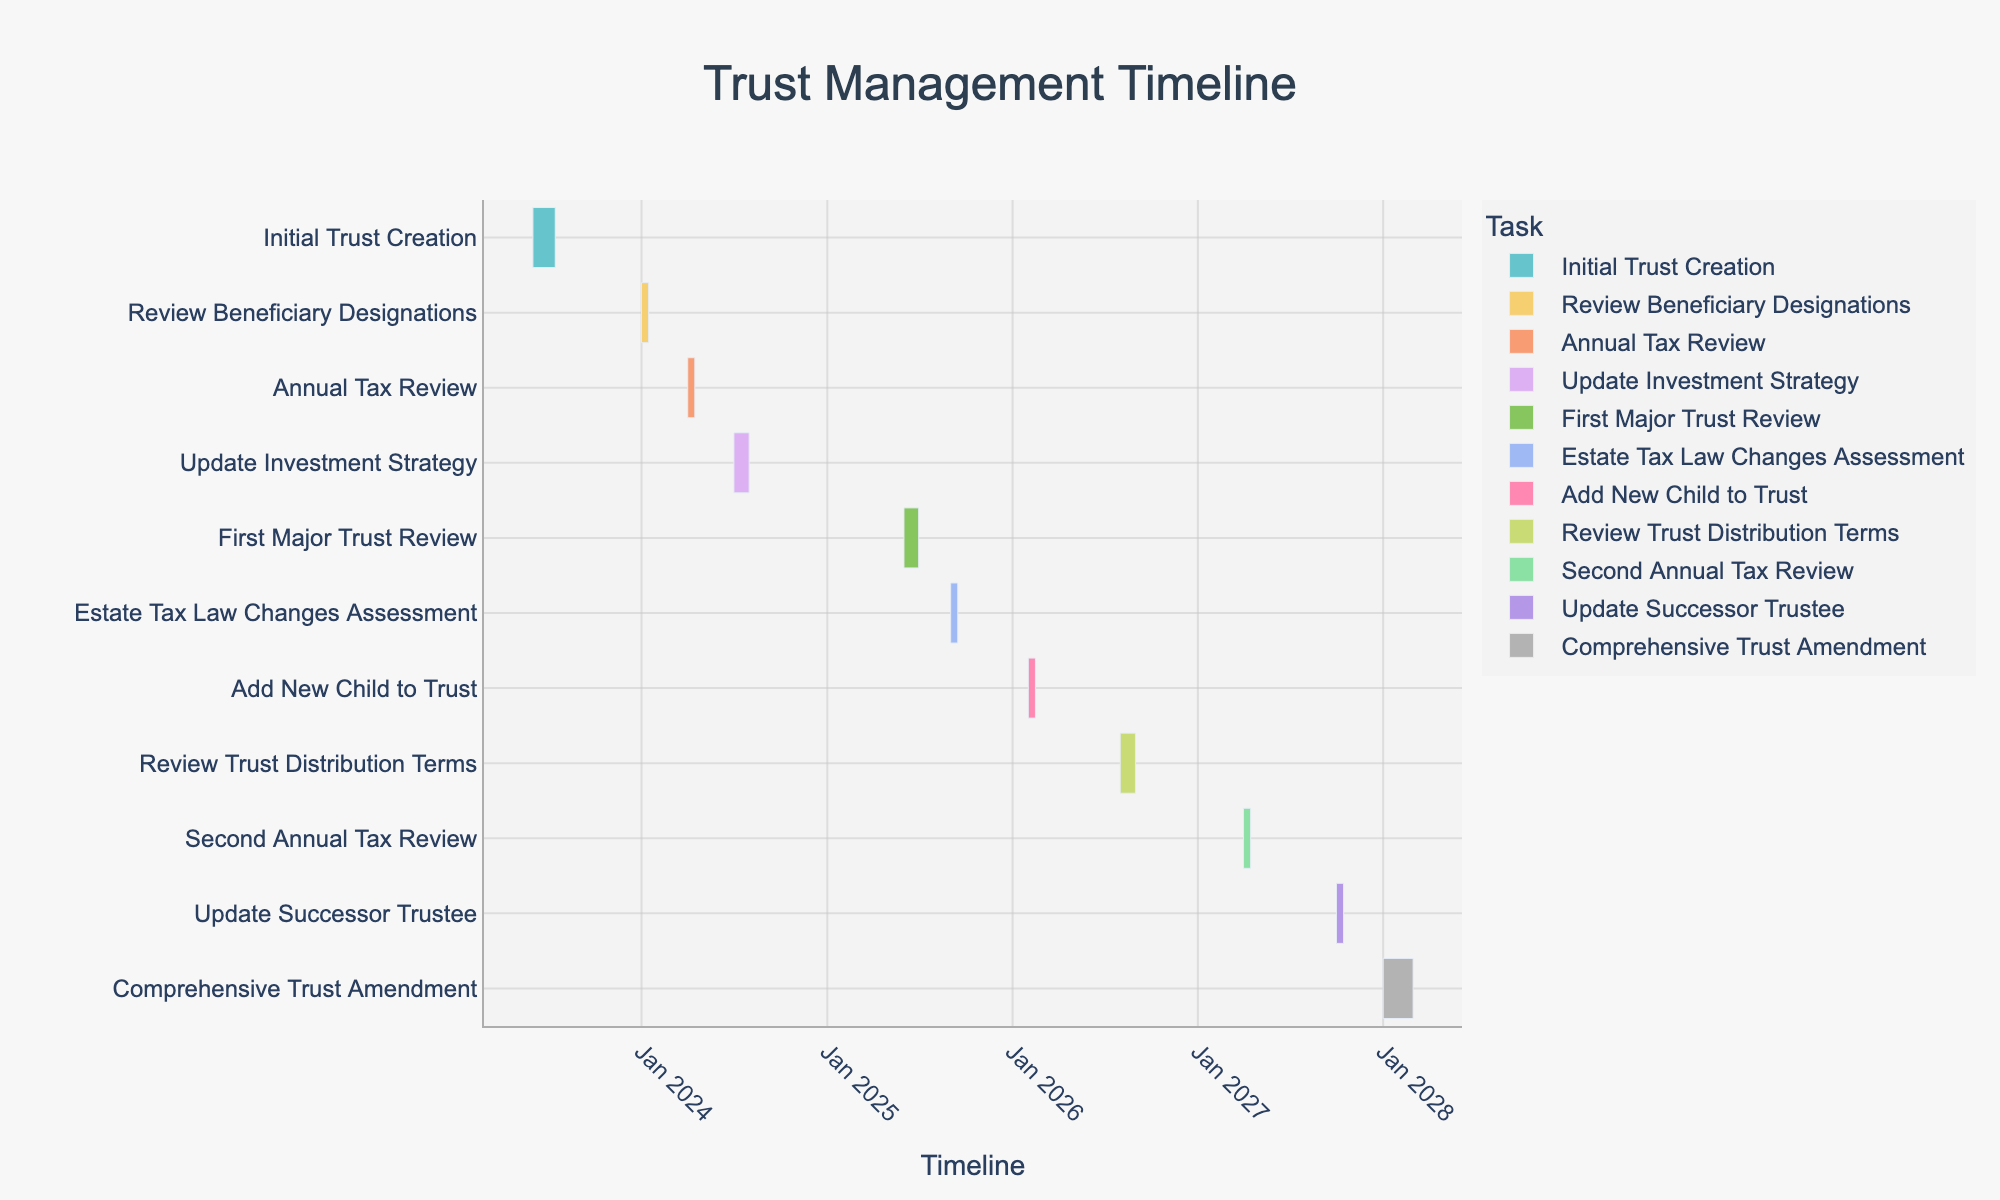What is the title of the Gantt chart? The title is displayed prominently at the top of the chart. This can be seen by the larger font size and central positioning.
Answer: Trust Management Timeline When does the "Initial Trust Creation" task start? By looking at the Gantt chart and finding the bar representing "Initial Trust Creation," we can see the start date on the x-axis.
Answer: June 1, 2023 How long is the "Comprehensive Trust Amendment" task scheduled to take? The duration can be calculated by determining the difference between the start and end dates. From January 1, 2028, to February 29, 2028, it covers 59 days.
Answer: 59 days Between which two tasks is there the longest interval without any scheduled activity? To find this, we need to identify the gaps between the end date of one task and the start date of the next. The significant gap appears between "Update Investment Strategy" (July 31, 2024) and "First Major Trust Review" (June 1, 2025).
Answer: Update Investment Strategy and First Major Trust Review What is the total number of trust review tasks scheduled up to 2028? By examining the Gantt chart and counting tasks related to trust reviews (Initial Trust Creation, First Major Trust Review, Comprehensive Trust Amendment), we get the number of these tasks.
Answer: 3 Which tasks are scheduled to occur within the year 2024? We can identify tasks falling within 2024 by looking at their schedule. These tasks are "Review Beneficiary Designations," "Annual Tax Review," and "Update Investment Strategy."
Answer: Review Beneficiary Designations, Annual Tax Review, Update Investment Strategy What is the duration of the trust review task that spans the shortest amount of time? The shortest duration can be found by checking all trust review tasks. "Review Beneficiary Designations" lasts from January 1, 2024, to January 15, 2024, covering 15 days.
Answer: 15 days When is the first "Annual Tax Review" scheduled, and how frequently do these reviews occur in the chart? We find "Annual Tax Review" starting on April 1, 2024, and notice the second review on April 1, 2027. The interval between reviews is approximately three years.
Answer: April 1, 2024, and approximately every three years 